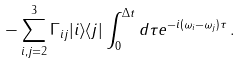Convert formula to latex. <formula><loc_0><loc_0><loc_500><loc_500>- \sum _ { i , j = 2 } ^ { 3 } \Gamma _ { i j } | i \rangle \langle j | \int _ { 0 } ^ { \Delta t } d \tau e ^ { - i ( \omega _ { i } - \omega _ { j } ) \tau } \, .</formula> 